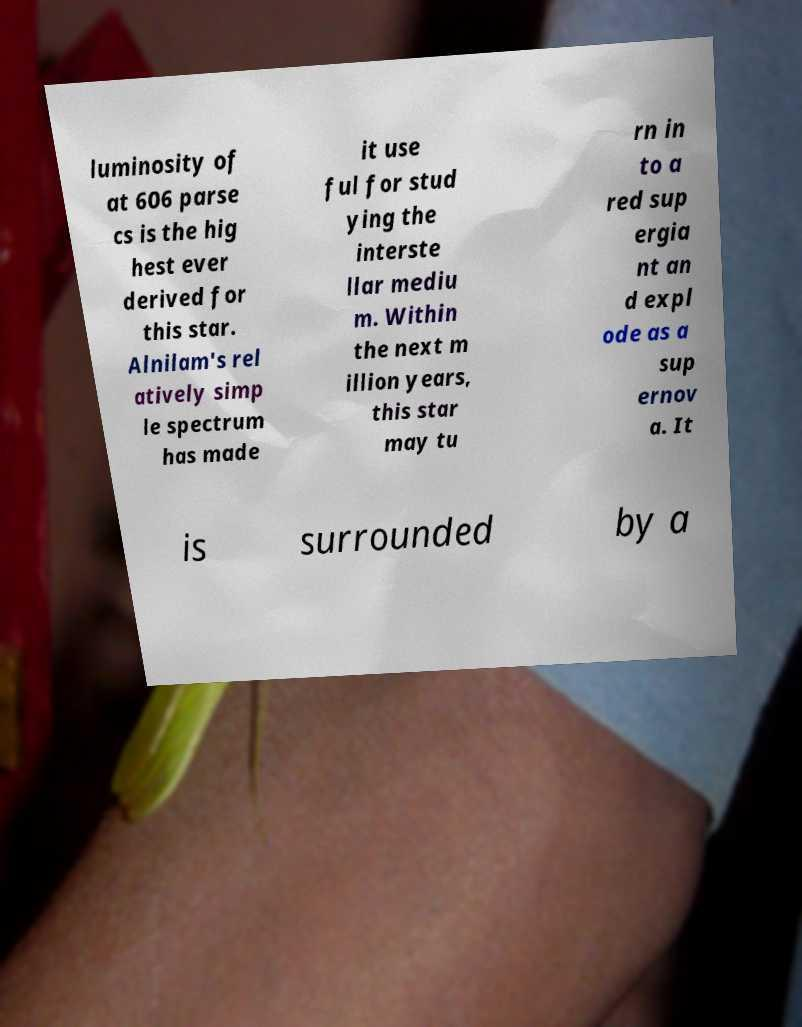Could you extract and type out the text from this image? luminosity of at 606 parse cs is the hig hest ever derived for this star. Alnilam's rel atively simp le spectrum has made it use ful for stud ying the interste llar mediu m. Within the next m illion years, this star may tu rn in to a red sup ergia nt an d expl ode as a sup ernov a. It is surrounded by a 